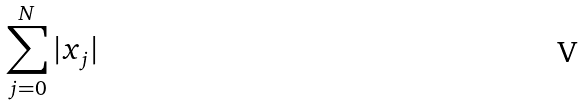Convert formula to latex. <formula><loc_0><loc_0><loc_500><loc_500>\sum _ { j = 0 } ^ { N } | x _ { j } |</formula> 